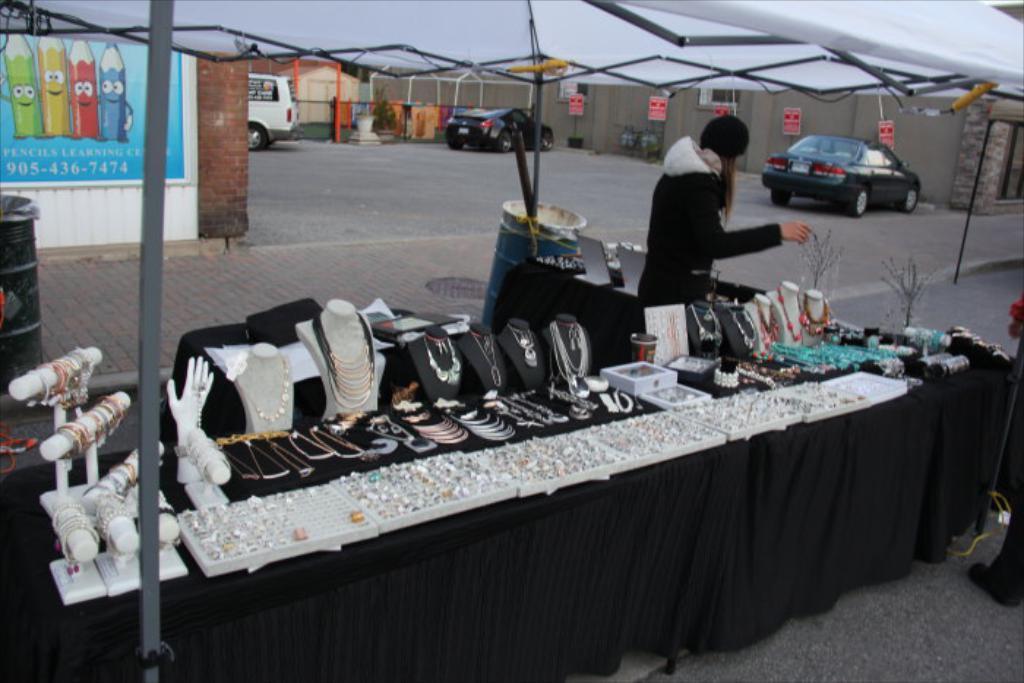How would you summarize this image in a sentence or two? In this image in the foreground there is a tent, under the tent there are few peoples, table, barrels, on which there are boxes contain arraigns, mannequin contain necklace set, bangle stand, on which there are some bangles, there is a road in the middle, on the road there are vehicles, and there is a wall, in front of the wall there are some boards attached, on the left side there is the wall on which there is a text, pencil images. 